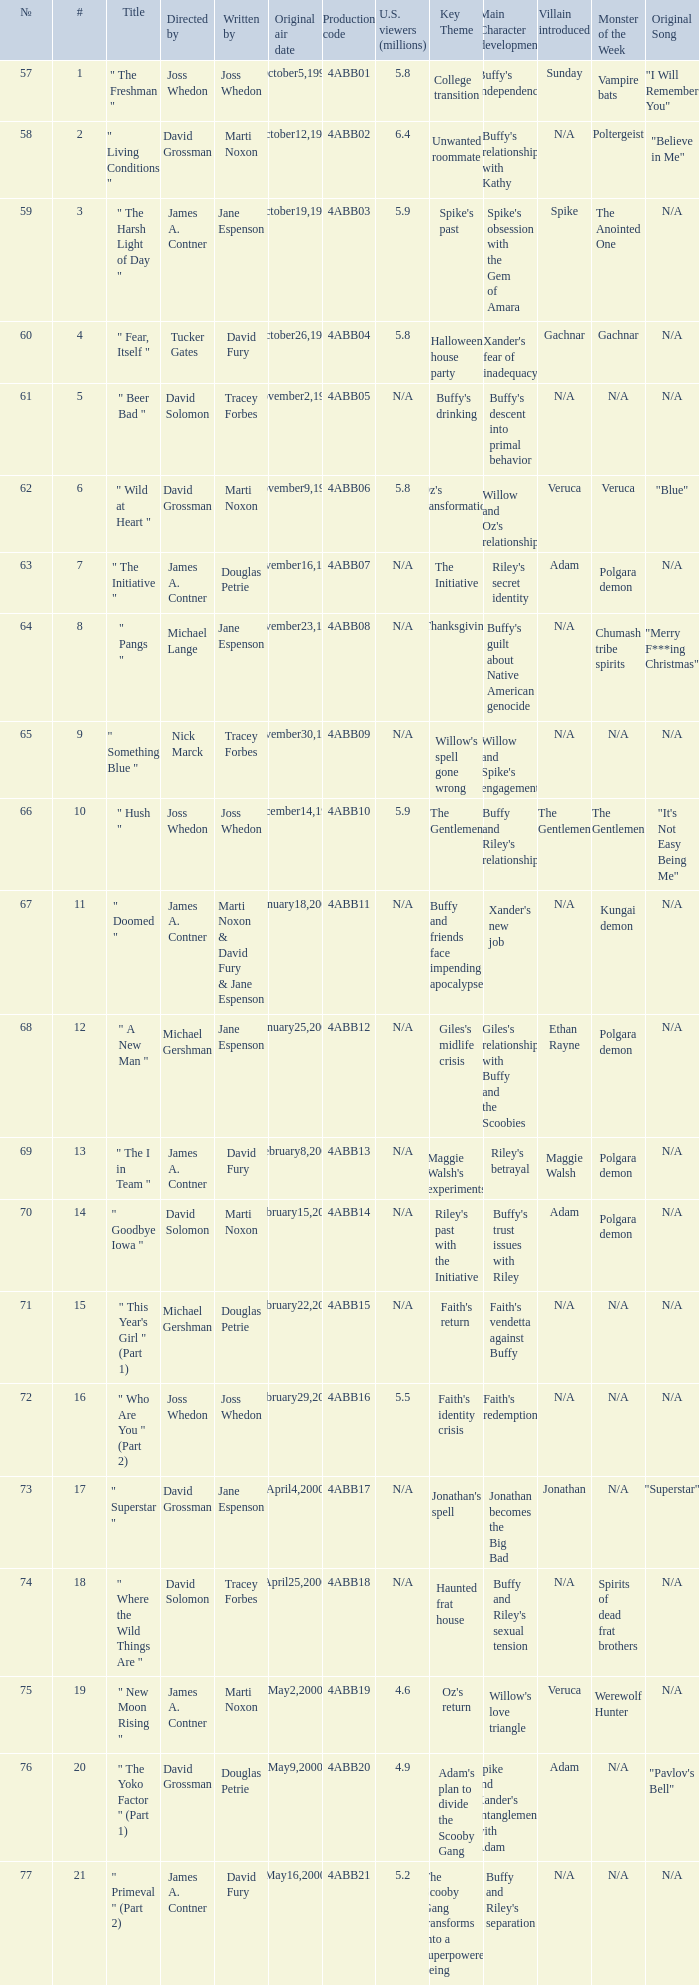Who wrote the episode which was directed by Nick Marck? Tracey Forbes. 